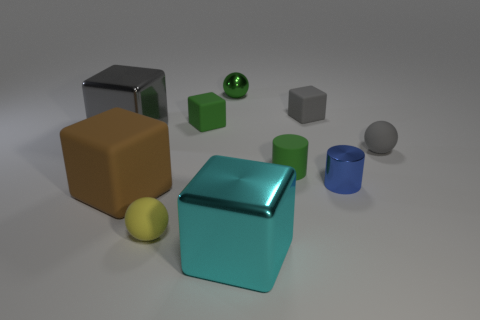Subtract all matte spheres. How many spheres are left? 1 Subtract all spheres. How many objects are left? 7 Subtract 2 blocks. How many blocks are left? 3 Subtract 1 blue cylinders. How many objects are left? 9 Subtract all gray cubes. Subtract all purple spheres. How many cubes are left? 3 Subtract all green balls. How many brown cylinders are left? 0 Subtract all small rubber cylinders. Subtract all tiny spheres. How many objects are left? 6 Add 1 large gray cubes. How many large gray cubes are left? 2 Add 3 tiny rubber cubes. How many tiny rubber cubes exist? 5 Subtract all green cylinders. How many cylinders are left? 1 